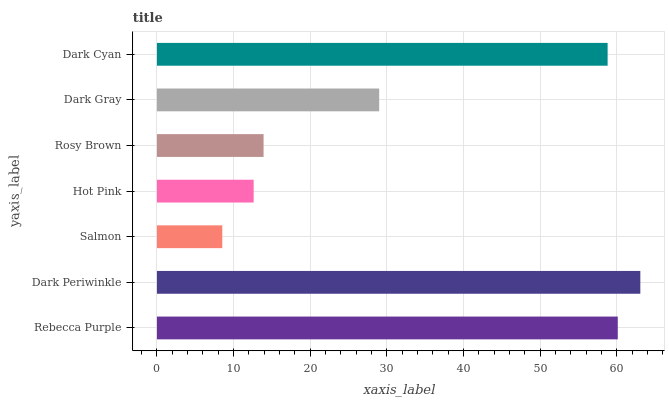Is Salmon the minimum?
Answer yes or no. Yes. Is Dark Periwinkle the maximum?
Answer yes or no. Yes. Is Dark Periwinkle the minimum?
Answer yes or no. No. Is Salmon the maximum?
Answer yes or no. No. Is Dark Periwinkle greater than Salmon?
Answer yes or no. Yes. Is Salmon less than Dark Periwinkle?
Answer yes or no. Yes. Is Salmon greater than Dark Periwinkle?
Answer yes or no. No. Is Dark Periwinkle less than Salmon?
Answer yes or no. No. Is Dark Gray the high median?
Answer yes or no. Yes. Is Dark Gray the low median?
Answer yes or no. Yes. Is Dark Cyan the high median?
Answer yes or no. No. Is Rebecca Purple the low median?
Answer yes or no. No. 